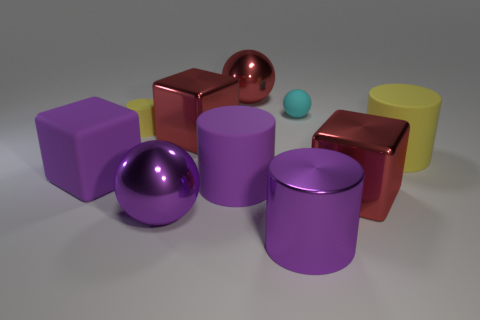What number of big red metallic objects are to the right of the large metal cylinder and behind the purple rubber cylinder?
Provide a succinct answer. 0. Is there a big yellow object to the right of the big cylinder in front of the red object that is on the right side of the tiny cyan ball?
Keep it short and to the point. Yes. What shape is the purple metallic thing that is the same size as the metallic cylinder?
Your answer should be compact. Sphere. Are there any big balls of the same color as the big shiny cylinder?
Provide a short and direct response. Yes. Is the small yellow rubber object the same shape as the large yellow thing?
Provide a short and direct response. Yes. How many tiny objects are either shiny balls or red metal objects?
Give a very brief answer. 0. There is a cube that is the same material as the tiny sphere; what color is it?
Offer a terse response. Purple. What number of things are made of the same material as the small cyan ball?
Ensure brevity in your answer.  4. There is a yellow matte cylinder that is on the right side of the tiny cyan object; does it have the same size as the sphere that is in front of the big purple matte block?
Provide a short and direct response. Yes. The cylinder that is on the right side of the metal block that is in front of the purple cube is made of what material?
Keep it short and to the point. Rubber. 